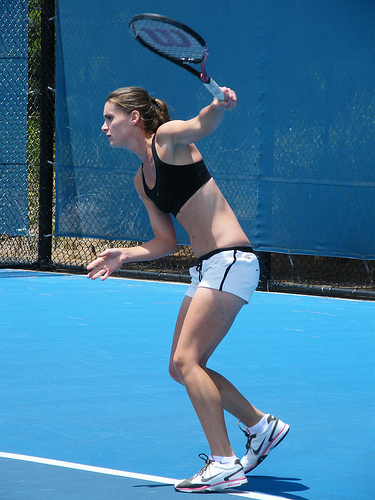What is the person holding? She is holding a tennis racket, an essential equipment for the sport she is depicted playing in the image. 